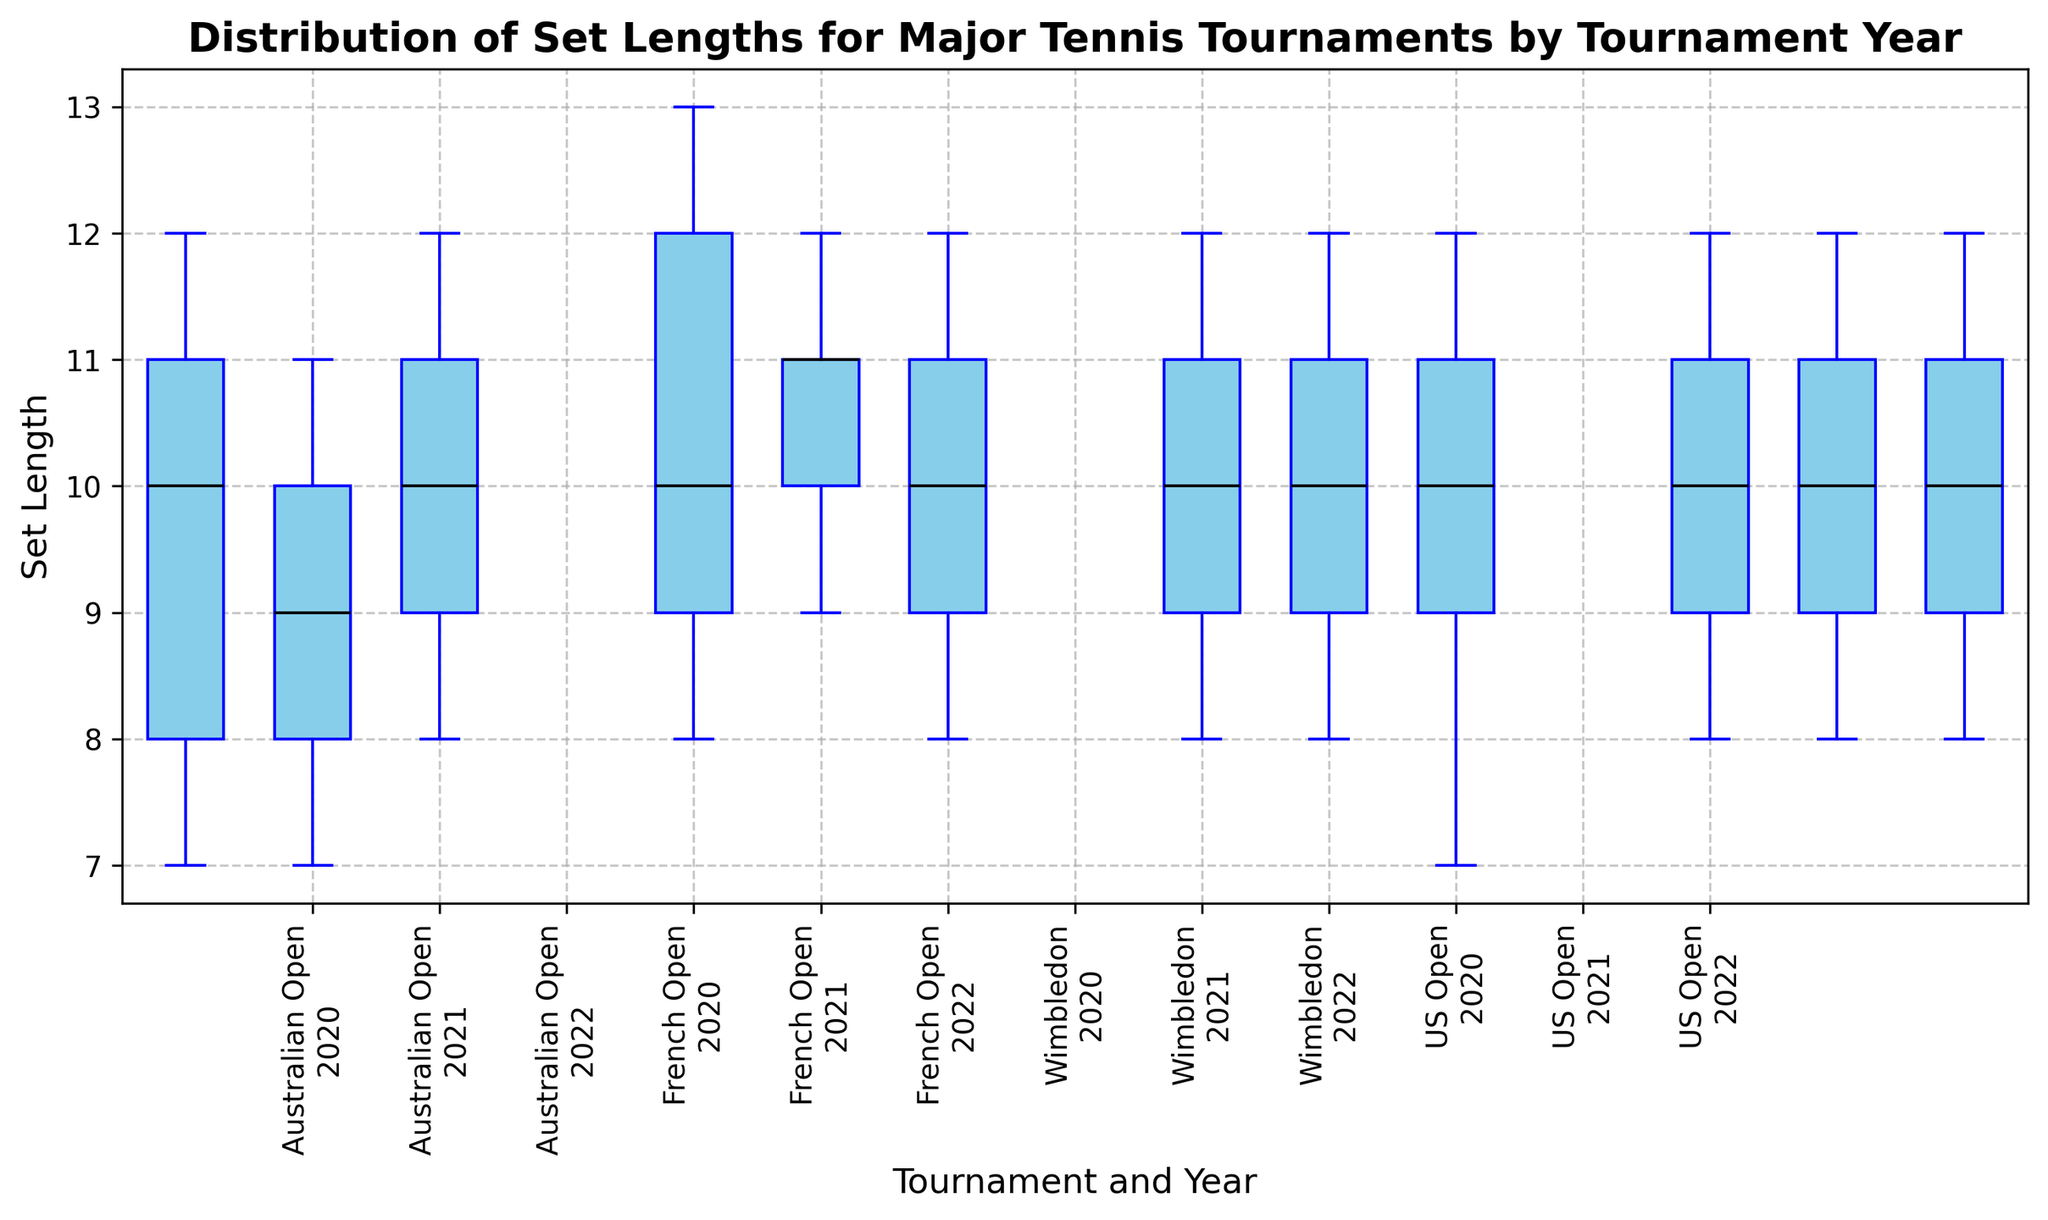What is the median set length of the Australian Open in 2020? To find the median, locate the middle value in the ordered set lengths. The Australian Open in 2020 has set lengths (7, 8, 10, 11, 12), and the middle value is 10.
Answer: 10 Which tournament had the highest median set length in 2020? Compare the median set lengths for each tournament in 2020. The Australian Open, French Open, Wimbledon, and US Open have median values of 10, 10, 10, and 10, respectively. However, visually checking the whiskers or specific fliers in the boxplots, the French Open tends to have higher upper ranges.
Answer: French Open What is the range of set lengths for the US Open in 2021? The range is calculated by subtracting the minimum value from the maximum value. For the US Open in 2021, the set lengths are (8, 9, 10, 11, 12), so the range is 12 - 8.
Answer: 4 How does the median set length of Wimbledon in 2020 compare to 2022? Compare the median values in Wimbledon for 2020 and 2022. Both have set lengths with median values around 10.
Answer: Equal Which tournament had the least variation in set lengths in 2021? The least variation can be identified by the shortest distance between the whiskers (min and max) in the boxplot. Visually, it looks like the Australian Open had the least variation in 2021.
Answer: Australian Open What is the interquartile range (IQR) for the French Open in 2022? IQR is calculated as the difference between the third quartile (Q3) and the first quartile (Q1). For the French Open in 2022, Q3 is around 11 and Q1 is around 9, so the IQR is 11 - 9.
Answer: 2 Which tournament had the most uniform distribution of set lengths in 2020? The most uniform distribution will have the most symmetric and tight boxplot. Wimbledon in 2020 appears to be the most uniform visually.
Answer: Wimbledon What are the maximum and minimum set lengths observed for the Australian Open across all years? Observing all boxplots for the Australian Open, the maximum set length is 12 and the minimum is 7.
Answer: Max: 12, Min: 7 Did any tournament experience an increase in median set length from 2020 to 2022? Check if the median (middle line of the box) in 2022 is higher compared to 2020. None of the medians seem to noticeably increase.
Answer: No 